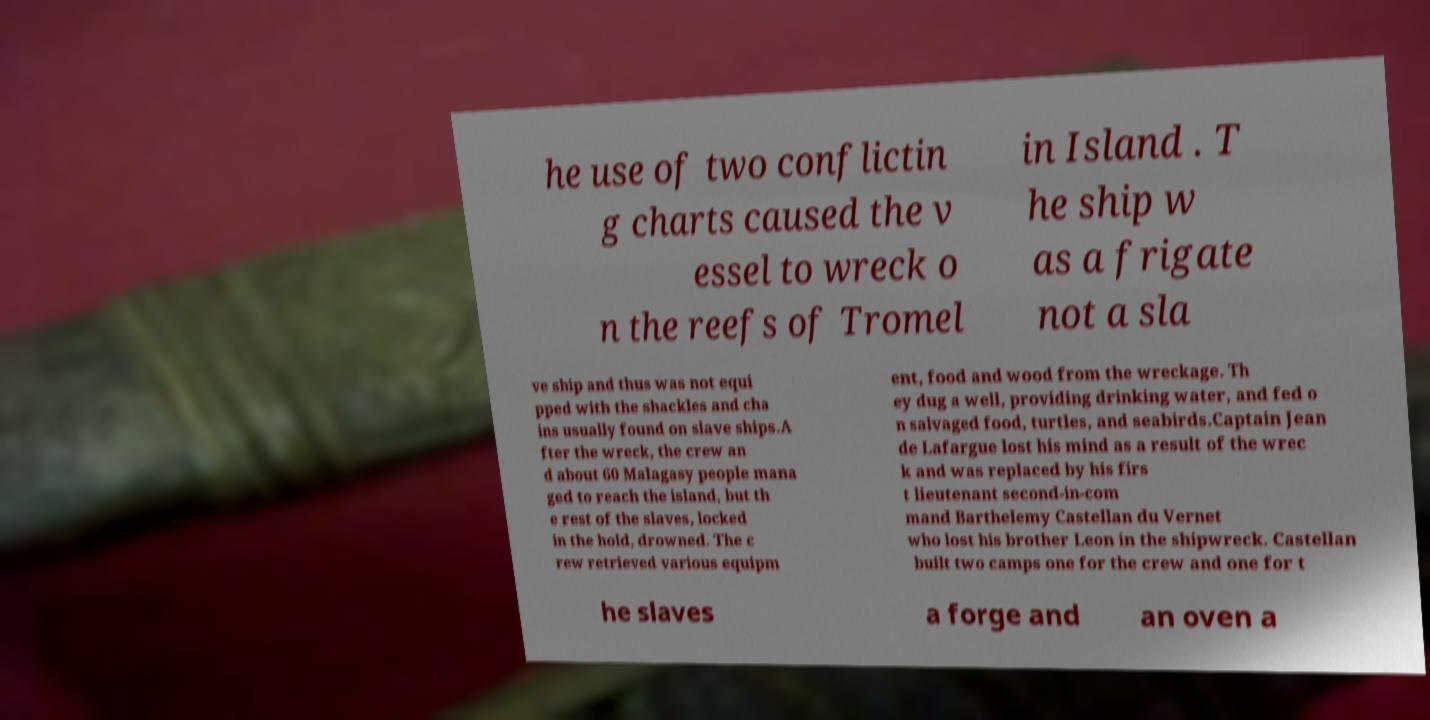Could you extract and type out the text from this image? he use of two conflictin g charts caused the v essel to wreck o n the reefs of Tromel in Island . T he ship w as a frigate not a sla ve ship and thus was not equi pped with the shackles and cha ins usually found on slave ships.A fter the wreck, the crew an d about 60 Malagasy people mana ged to reach the island, but th e rest of the slaves, locked in the hold, drowned. The c rew retrieved various equipm ent, food and wood from the wreckage. Th ey dug a well, providing drinking water, and fed o n salvaged food, turtles, and seabirds.Captain Jean de Lafargue lost his mind as a result of the wrec k and was replaced by his firs t lieutenant second-in-com mand Barthelemy Castellan du Vernet who lost his brother Leon in the shipwreck. Castellan built two camps one for the crew and one for t he slaves a forge and an oven a 